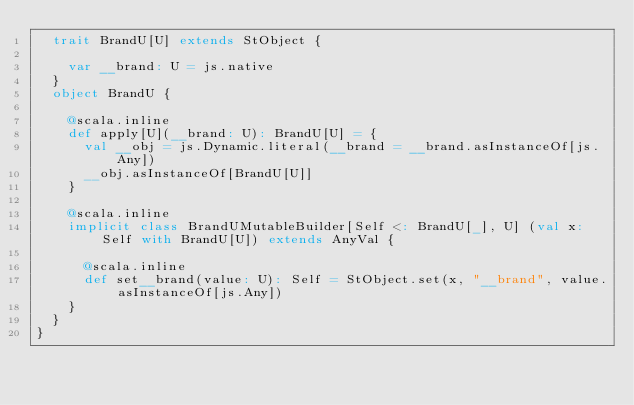<code> <loc_0><loc_0><loc_500><loc_500><_Scala_>  trait BrandU[U] extends StObject {
    
    var __brand: U = js.native
  }
  object BrandU {
    
    @scala.inline
    def apply[U](__brand: U): BrandU[U] = {
      val __obj = js.Dynamic.literal(__brand = __brand.asInstanceOf[js.Any])
      __obj.asInstanceOf[BrandU[U]]
    }
    
    @scala.inline
    implicit class BrandUMutableBuilder[Self <: BrandU[_], U] (val x: Self with BrandU[U]) extends AnyVal {
      
      @scala.inline
      def set__brand(value: U): Self = StObject.set(x, "__brand", value.asInstanceOf[js.Any])
    }
  }
}
</code> 